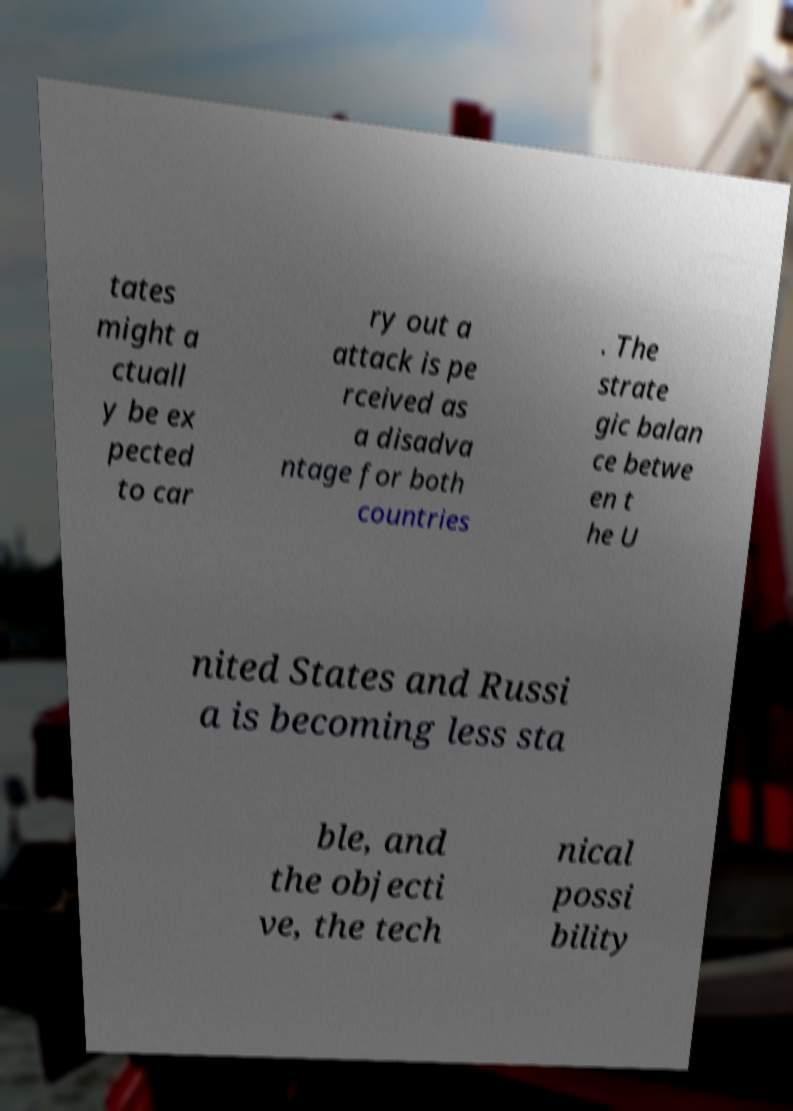Can you accurately transcribe the text from the provided image for me? tates might a ctuall y be ex pected to car ry out a attack is pe rceived as a disadva ntage for both countries . The strate gic balan ce betwe en t he U nited States and Russi a is becoming less sta ble, and the objecti ve, the tech nical possi bility 